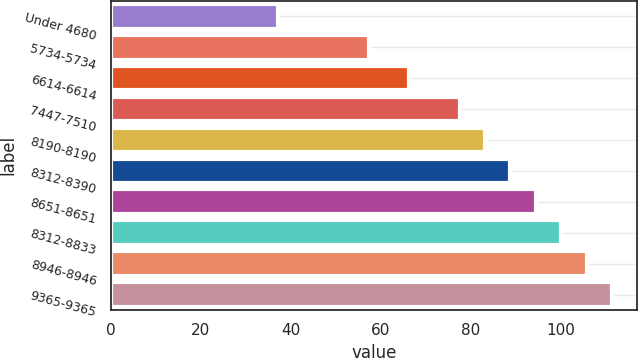Convert chart to OTSL. <chart><loc_0><loc_0><loc_500><loc_500><bar_chart><fcel>Under 4680<fcel>5734-5734<fcel>6614-6614<fcel>7447-7510<fcel>8190-8190<fcel>8312-8390<fcel>8651-8651<fcel>8312-8833<fcel>8946-8946<fcel>9365-9365<nl><fcel>37.18<fcel>57.34<fcel>66.14<fcel>77.44<fcel>83.09<fcel>88.74<fcel>94.39<fcel>100.04<fcel>105.69<fcel>111.34<nl></chart> 